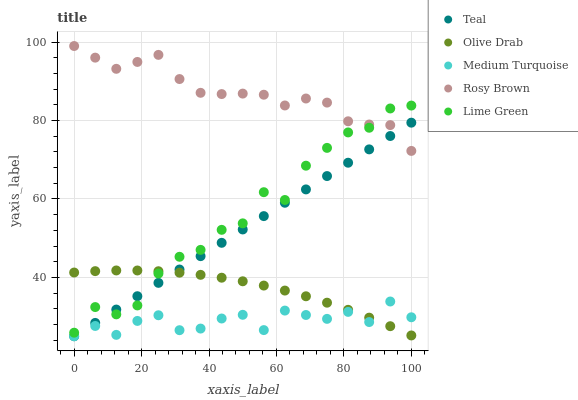Does Medium Turquoise have the minimum area under the curve?
Answer yes or no. Yes. Does Rosy Brown have the maximum area under the curve?
Answer yes or no. Yes. Does Lime Green have the minimum area under the curve?
Answer yes or no. No. Does Lime Green have the maximum area under the curve?
Answer yes or no. No. Is Teal the smoothest?
Answer yes or no. Yes. Is Lime Green the roughest?
Answer yes or no. Yes. Is Rosy Brown the smoothest?
Answer yes or no. No. Is Rosy Brown the roughest?
Answer yes or no. No. Does Medium Turquoise have the lowest value?
Answer yes or no. Yes. Does Lime Green have the lowest value?
Answer yes or no. No. Does Rosy Brown have the highest value?
Answer yes or no. Yes. Does Lime Green have the highest value?
Answer yes or no. No. Is Olive Drab less than Rosy Brown?
Answer yes or no. Yes. Is Rosy Brown greater than Medium Turquoise?
Answer yes or no. Yes. Does Olive Drab intersect Teal?
Answer yes or no. Yes. Is Olive Drab less than Teal?
Answer yes or no. No. Is Olive Drab greater than Teal?
Answer yes or no. No. Does Olive Drab intersect Rosy Brown?
Answer yes or no. No. 